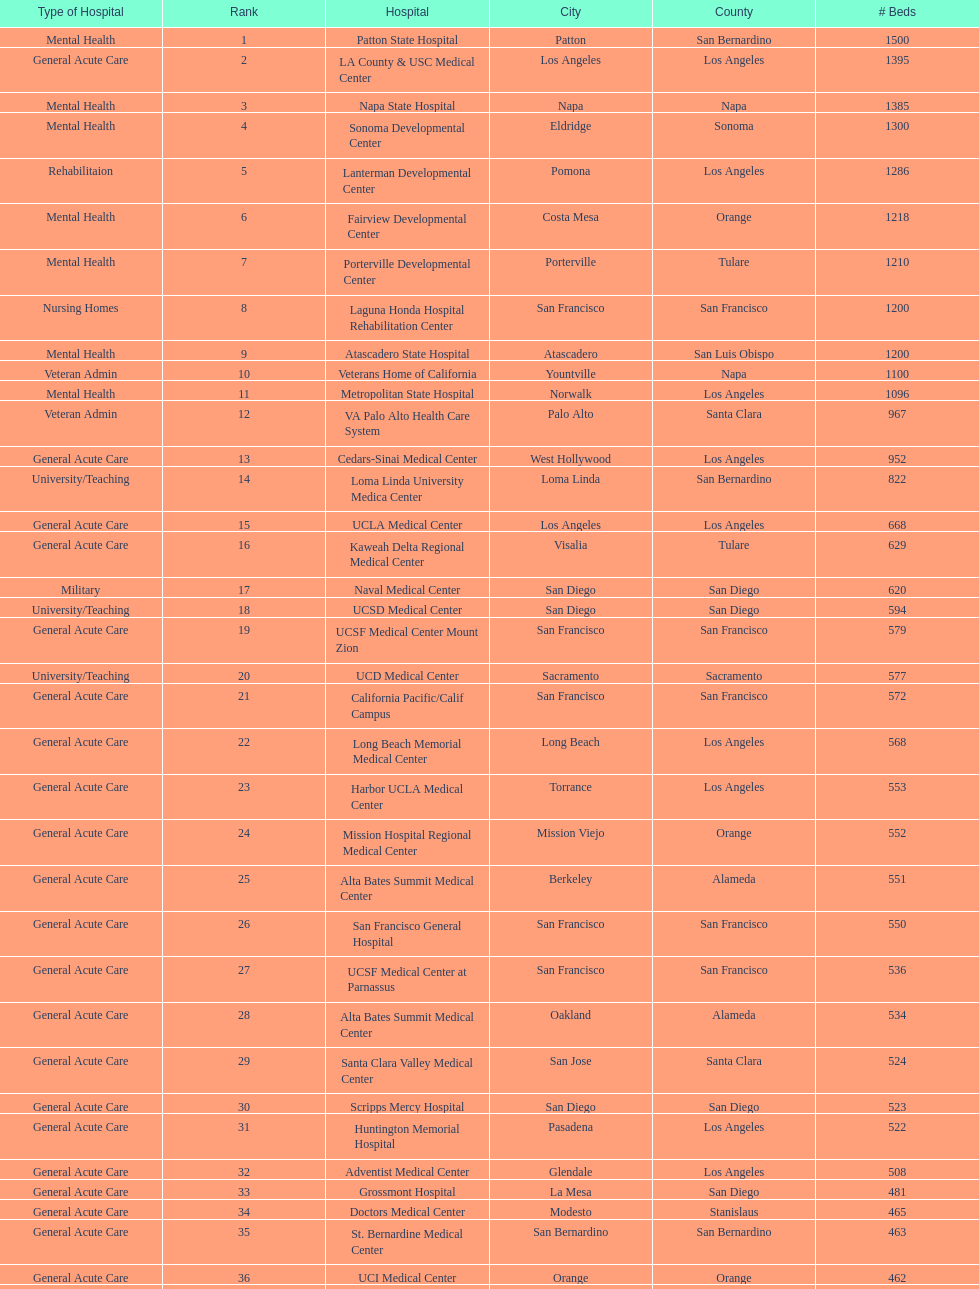How much larger (in number of beds) was the largest hospital in california than the 50th largest? 1071. 